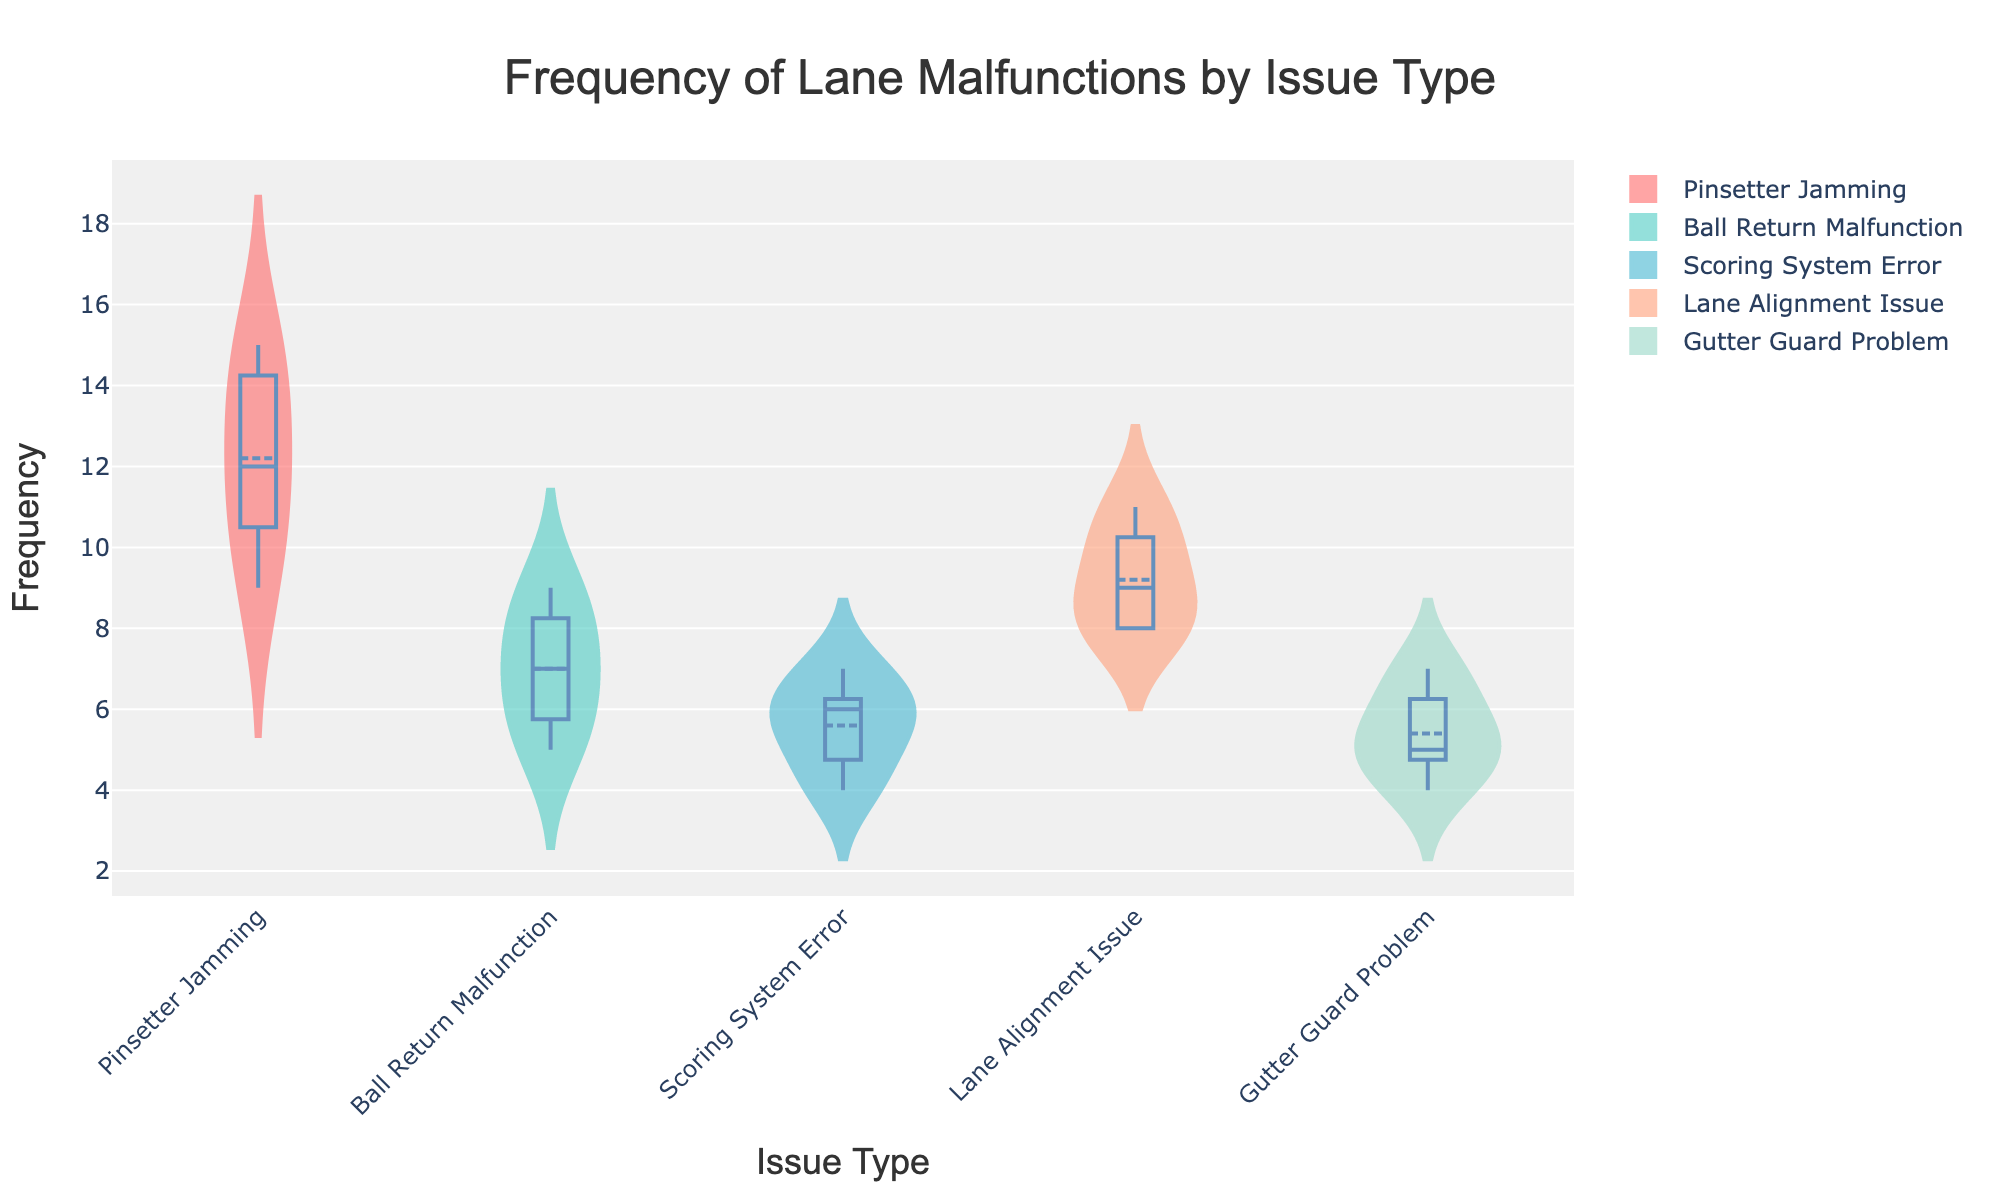What is the title of the chart? The title is prominently displayed at the top of the chart. It reads, "Frequency of Lane Malfunctions by Issue Type".
Answer: Frequency of Lane Malfunctions by Issue Type What are the issue types displayed on the x-axis? Each violin plot on the x-axis represents a different type of issue. The issue types are: "Pinsetter Jamming", "Ball Return Malfunction", "Scoring System Error", "Lane Alignment Issue", and "Gutter Guard Problem".
Answer: Pinsetter Jamming, Ball Return Malfunction, Scoring System Error, Lane Alignment Issue, Gutter Guard Problem Which issue type has the highest median frequency? On the violin plot, the horizontal line within the box plot overlay represents the median. The issue type with the highest median frequency can be identified by finding the highest median line. "Pinsetter Jamming" has the highest median frequency.
Answer: Pinsetter Jamming What is the median frequency of Lane Alignment Issue? The median frequency is represented by the horizontal line within the box plot overlay on the violin chart for "Lane Alignment Issue". The line intersects at around 9.
Answer: 9 How many lanes reported a frequency of 7 for Ball Return Malfunction? In a Violin Chart, the density of points is indicated by the width of the violin. The wider the violin at a specific frequency, the more lanes reported that frequency. For Ball Return Malfunction, the violin is thin at frequency 7, indicating fewer lanes. Only one lane reported a frequency of 7.
Answer: 1 Which issue type shows the most variability in frequency? Variability can be assessed by looking at the spread and width of the violin plots. "Pinsetter Jamming" shows the widest and most spread-out violin, indicating the most variability in frequency.
Answer: Pinsetter Jamming Is the mean frequency generally higher or lower than the median for Scoring System Error? The mean is represented by a vertical line within each violin plot. Comparing it to the median line within the box plot overlay, for "Scoring System Error," the mean appears to be slightly higher than the median.
Answer: Higher What is the interquartile range (IQR) of Gutter Guard Problem frequency? The IQR is the distance between the first quartile (Q1) and the third quartile (Q3), represented by the top and bottom boundaries of the box within the box plot overlay. For "Gutter Guard Problem", Q1 is at 5 and Q3 is at 6, so IQR = 6 - 5 = 1.
Answer: 1 Which lane shows the lowest frequency for Pinsetter Jamming? The lowest frequency for "Pinsetter Jamming" is represented by the lowest point of its violin plot. Lane 2 reports the lowest frequency at 9.
Answer: Lane 2 Across all issue types, which one has a median frequency closest to the mean frequency of Scoring System Error? First, identify the mean frequency of "Scoring System Error" from its vertical mean line, which is around 5.6. Then, compare the median frequencies of other issue types. "Gutter Guard Problem" has its median at about 5, closest to 5.6.
Answer: Gutter Guard Problem 